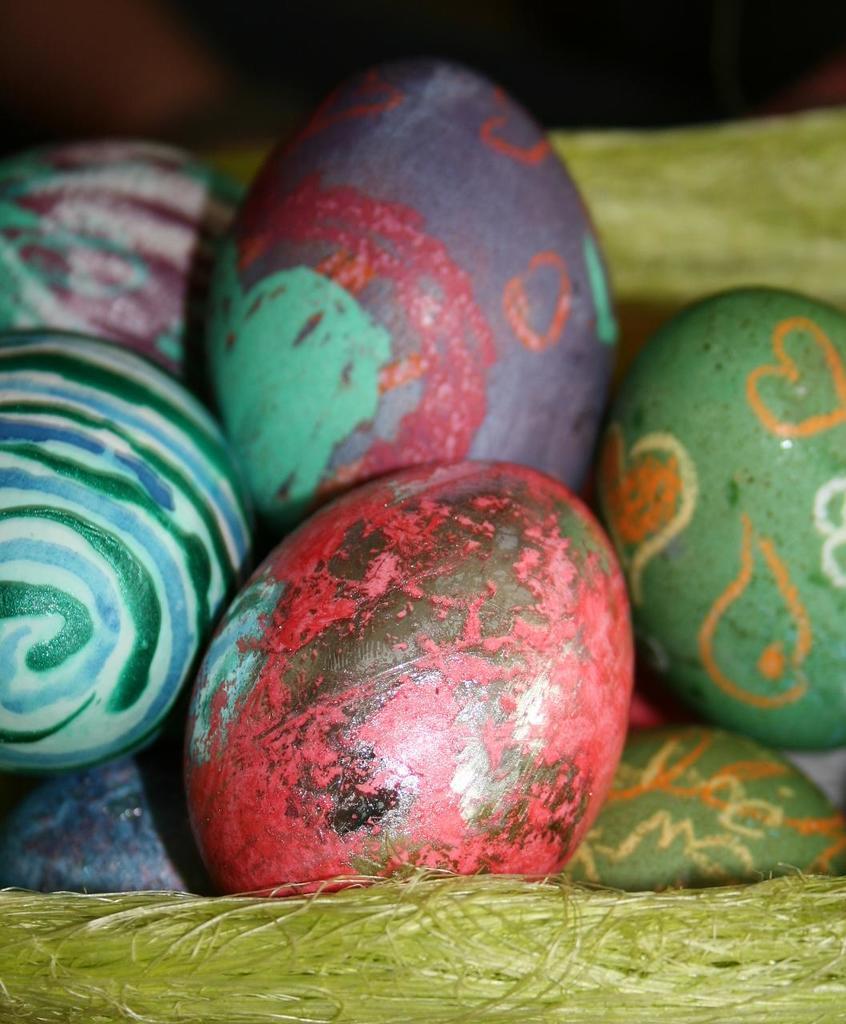Could you give a brief overview of what you see in this image? In this image, we can see some eggs with painting on it and the eggs are on the nest. At the top, we can see black color. 